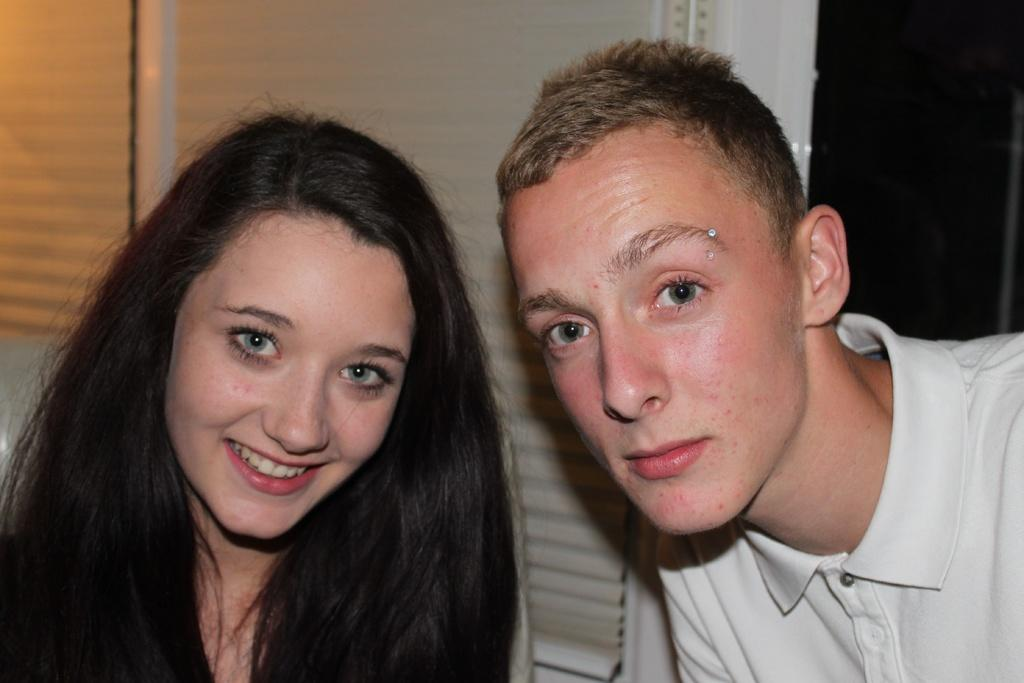How many people are present in the image? There are two persons in the image. What can be seen in the background of the image? There is a wall visible in the background of the image. What type of coal is being used by the persons in the image? There is no coal present in the image; it features two persons and a wall in the background. 